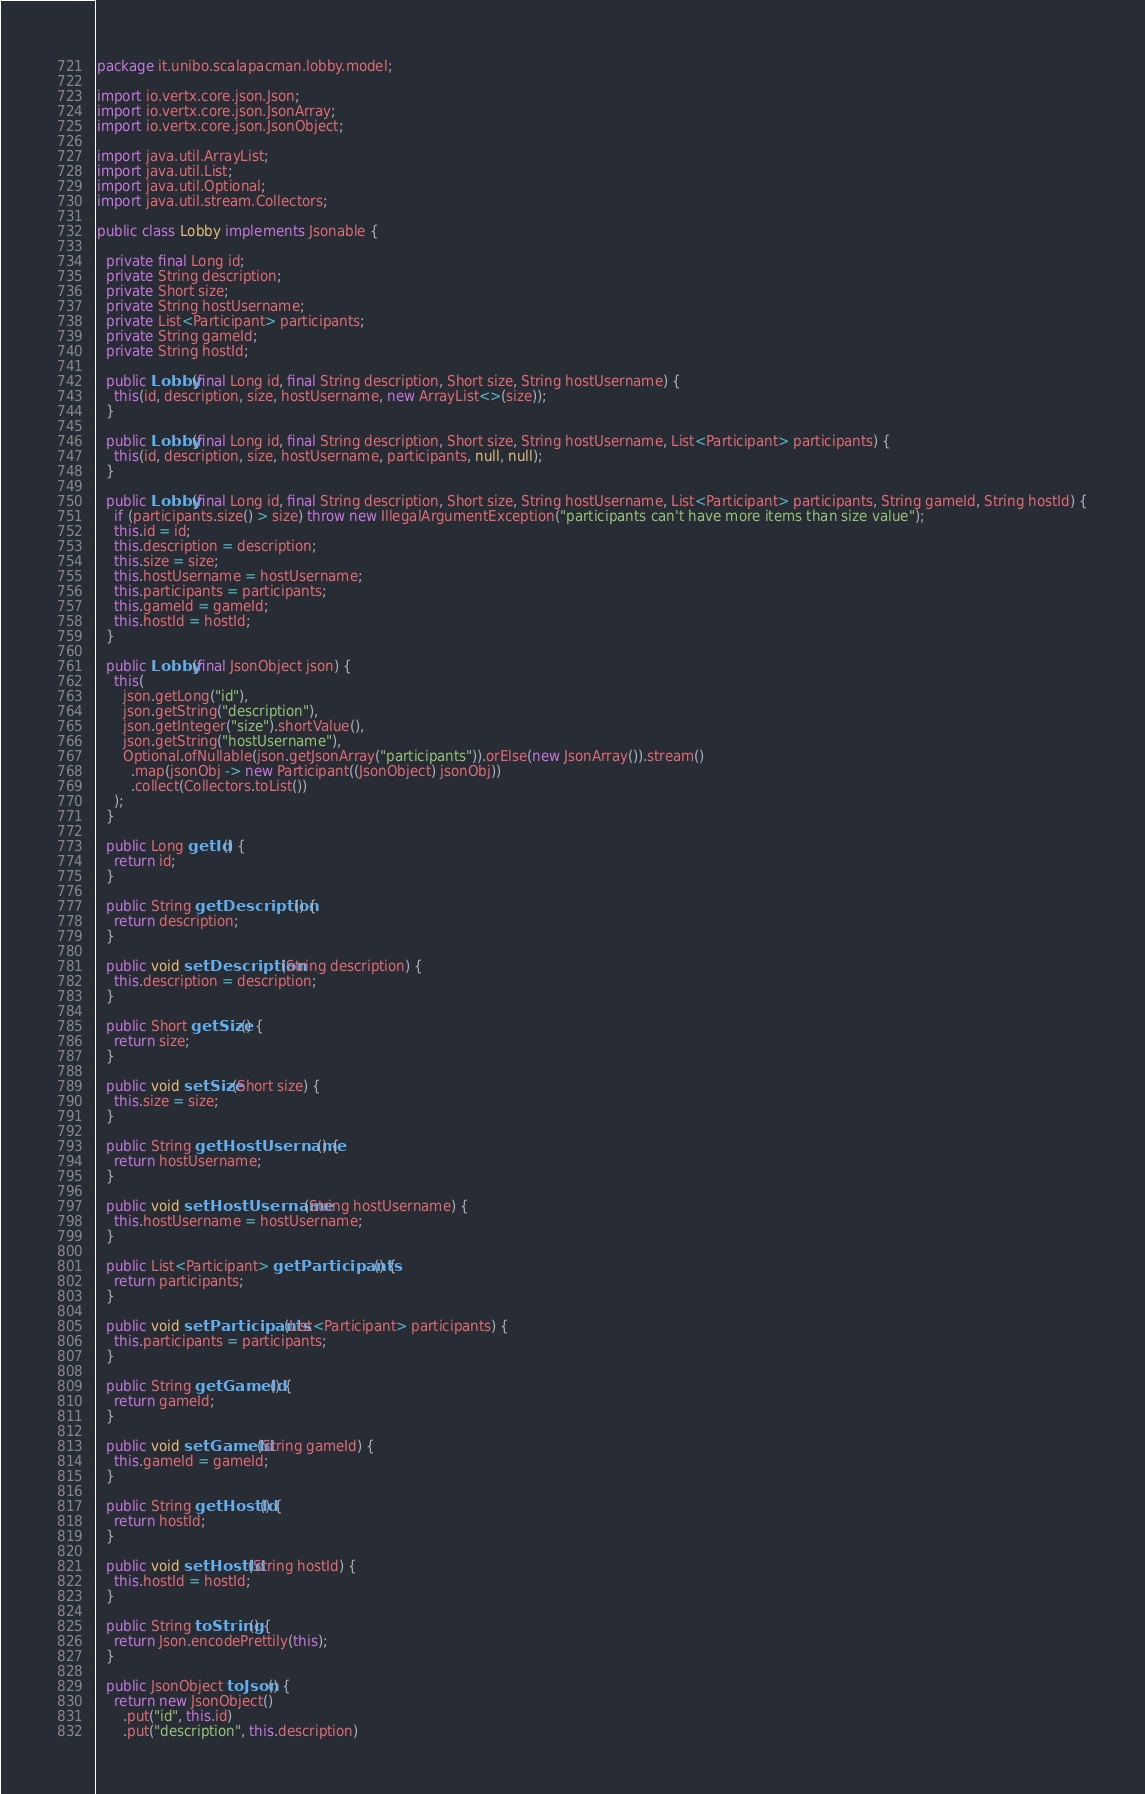Convert code to text. <code><loc_0><loc_0><loc_500><loc_500><_Java_>package it.unibo.scalapacman.lobby.model;

import io.vertx.core.json.Json;
import io.vertx.core.json.JsonArray;
import io.vertx.core.json.JsonObject;

import java.util.ArrayList;
import java.util.List;
import java.util.Optional;
import java.util.stream.Collectors;

public class Lobby implements Jsonable {

  private final Long id;
  private String description;
  private Short size;
  private String hostUsername;
  private List<Participant> participants;
  private String gameId;
  private String hostId;

  public Lobby(final Long id, final String description, Short size, String hostUsername) {
    this(id, description, size, hostUsername, new ArrayList<>(size));
  }

  public Lobby(final Long id, final String description, Short size, String hostUsername, List<Participant> participants) {
    this(id, description, size, hostUsername, participants, null, null);
  }

  public Lobby(final Long id, final String description, Short size, String hostUsername, List<Participant> participants, String gameId, String hostId) {
    if (participants.size() > size) throw new IllegalArgumentException("participants can't have more items than size value");
    this.id = id;
    this.description = description;
    this.size = size;
    this.hostUsername = hostUsername;
    this.participants = participants;
    this.gameId = gameId;
    this.hostId = hostId;
  }

  public Lobby(final JsonObject json) {
    this(
      json.getLong("id"),
      json.getString("description"),
      json.getInteger("size").shortValue(),
      json.getString("hostUsername"),
      Optional.ofNullable(json.getJsonArray("participants")).orElse(new JsonArray()).stream()
        .map(jsonObj -> new Participant((JsonObject) jsonObj))
        .collect(Collectors.toList())
    );
  }

  public Long getId() {
    return id;
  }

  public String getDescription() {
    return description;
  }

  public void setDescription(String description) {
    this.description = description;
  }

  public Short getSize() {
    return size;
  }

  public void setSize(Short size) {
    this.size = size;
  }

  public String getHostUsername() {
    return hostUsername;
  }

  public void setHostUsername(String hostUsername) {
    this.hostUsername = hostUsername;
  }

  public List<Participant> getParticipants() {
    return participants;
  }

  public void setParticipants(List<Participant> participants) {
    this.participants = participants;
  }

  public String getGameId() {
    return gameId;
  }

  public void setGameId(String gameId) {
    this.gameId = gameId;
  }

  public String getHostId() {
    return hostId;
  }

  public void setHostId(String hostId) {
    this.hostId = hostId;
  }

  public String toString() {
    return Json.encodePrettily(this);
  }

  public JsonObject toJson() {
    return new JsonObject()
      .put("id", this.id)
      .put("description", this.description)</code> 